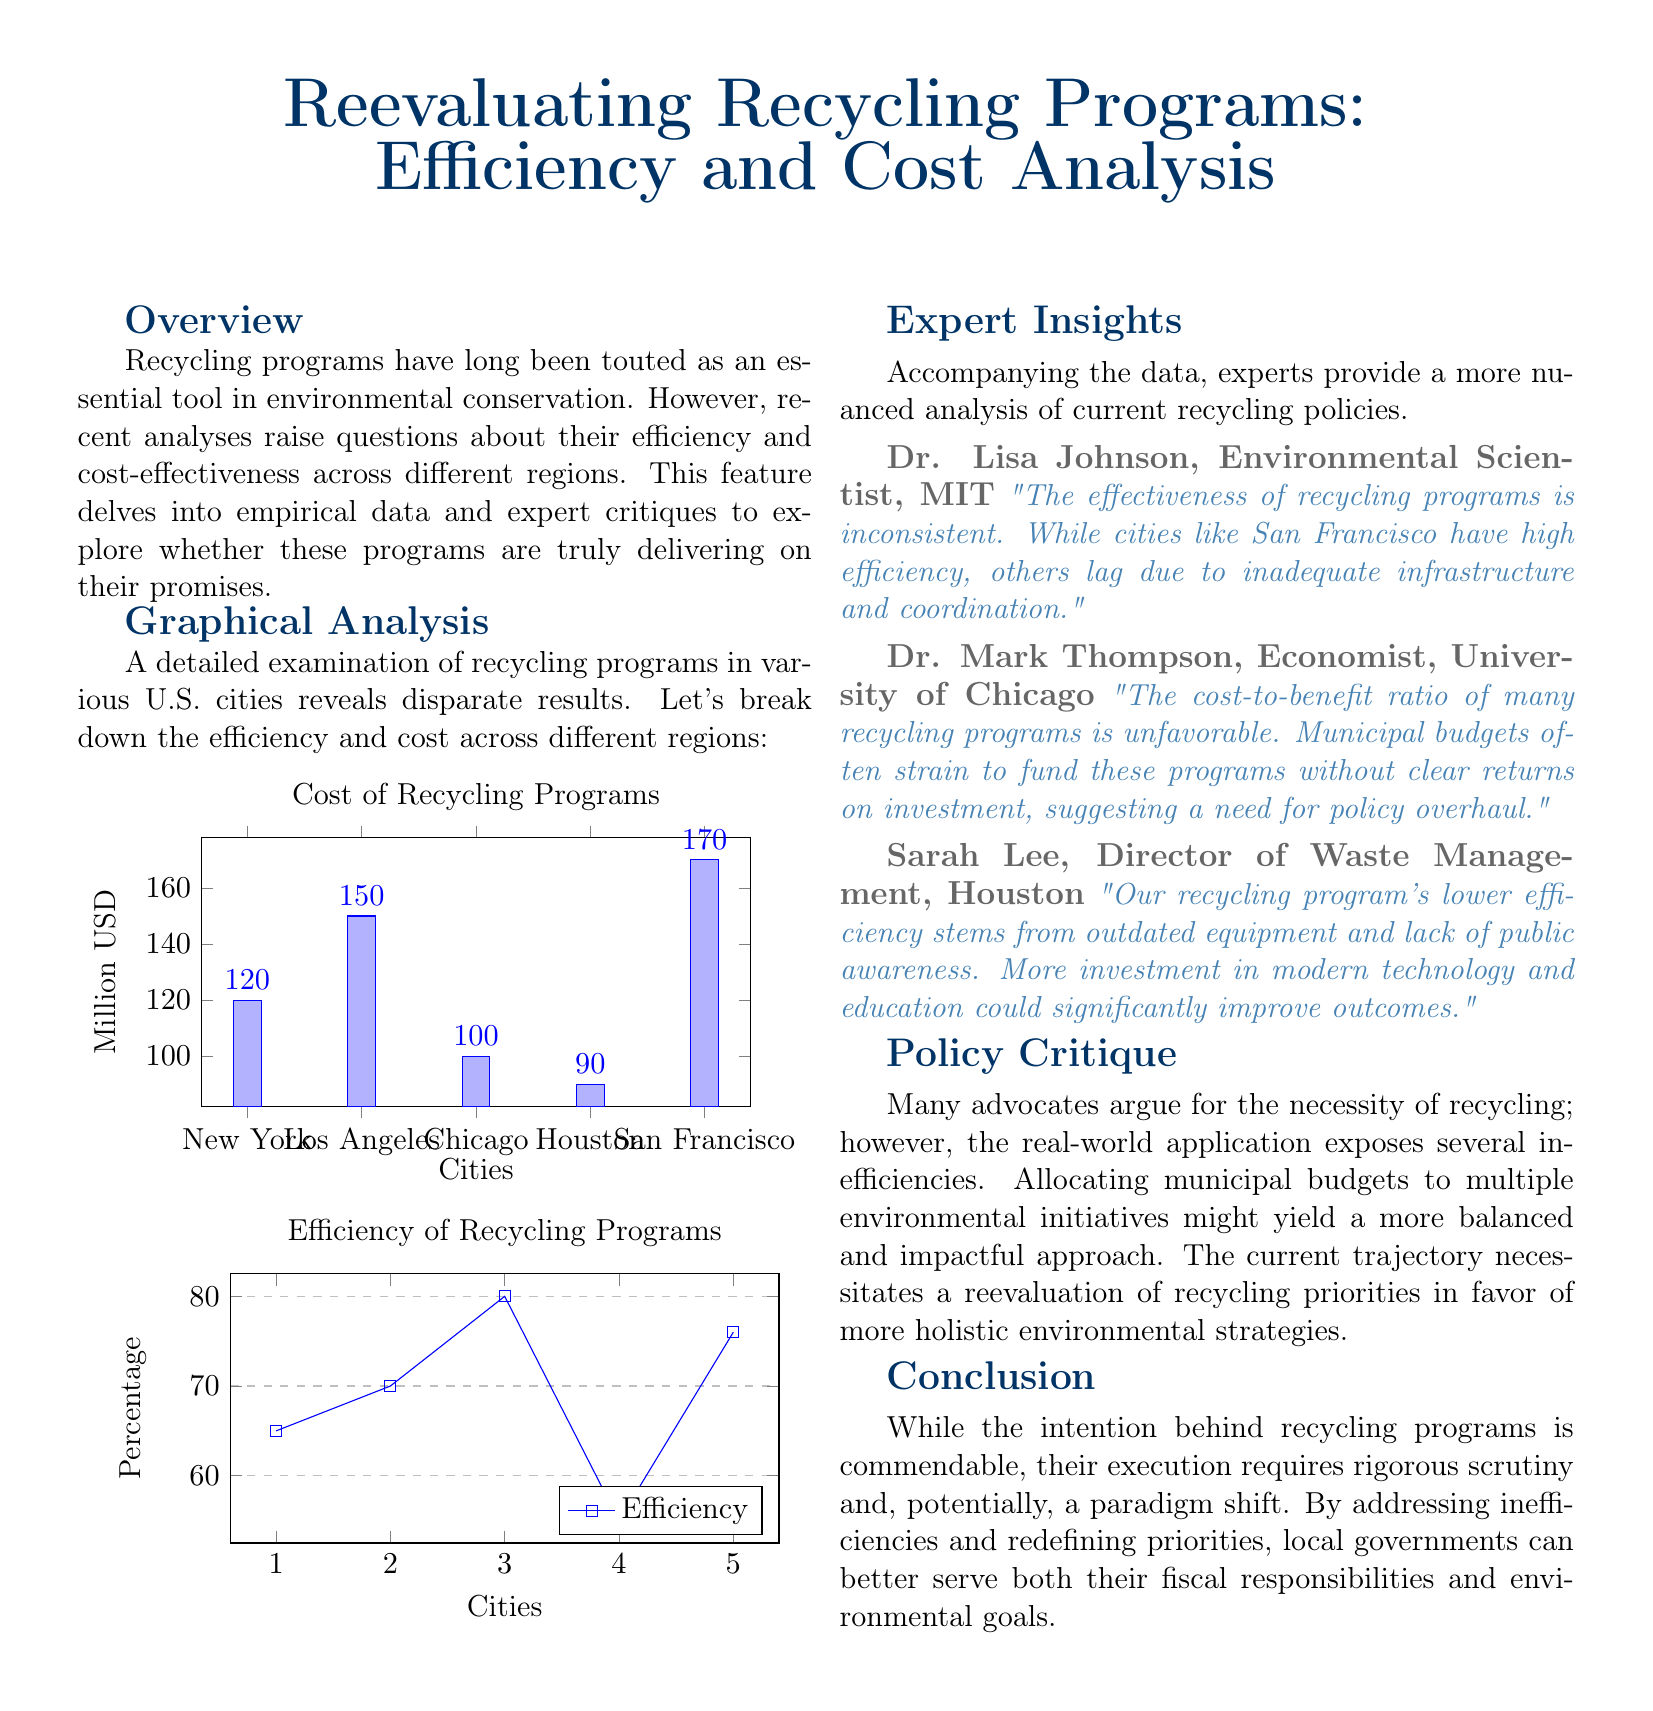What is the title of the document? The title is prominently displayed at the top of the document, summarizing its main focus.
Answer: Reevaluating Recycling Programs: Efficiency and Cost Analysis Which city has the highest cost of recycling programs? The cost of recycling programs is depicted in a bar graph comparing different cities.
Answer: San Francisco What is the recycling efficiency percentage for Los Angeles? The recycling efficiency is shown in a graph listing percentage values per city.
Answer: 70 Who provided insights as an Environmental Scientist? The experts' insights section lists their names and professions, including roles related to environmental science.
Answer: Dr. Lisa Johnson What does Dr. Mark Thompson suggest regarding municipal budgets? His commentary discusses the financial implications of recycling programs, highlighting challenges related to costs.
Answer: Unfavorable Which city has the lowest efficiency in its recycling program? Comparing the efficiency data on the graph reveals discrepancies among different cities.
Answer: Houston What recommendation does Sarah Lee make for improving recycling outcomes? The document includes direct quotes from experts proposing solutions to enhance recycling program effectiveness.
Answer: Investment in modern technology What type of analysis is presented in the document? The overview section describes the nature of the study, emphasizing critiques supported by empirical evidence.
Answer: Efficiency and Cost Analysis 